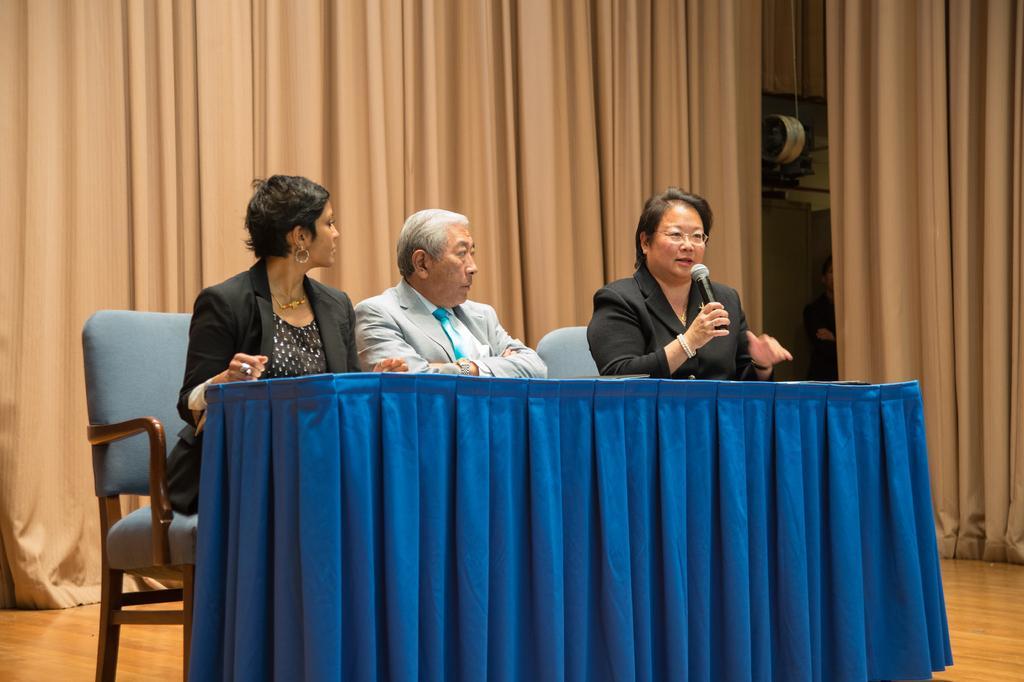Describe this image in one or two sentences. In this image, three peoples are sat on the chair. in-front of them there is a blue color table. On right side, woman is holding a microphone , she is talking. At the background, we can see curtains and a person is standing here. 